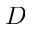Convert formula to latex. <formula><loc_0><loc_0><loc_500><loc_500>D</formula> 